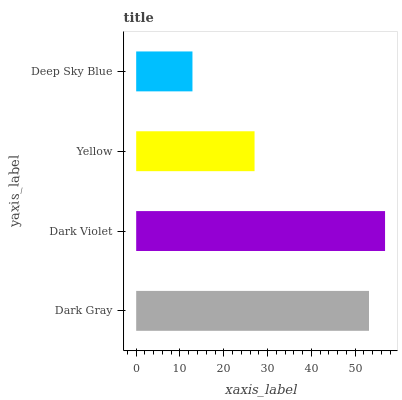Is Deep Sky Blue the minimum?
Answer yes or no. Yes. Is Dark Violet the maximum?
Answer yes or no. Yes. Is Yellow the minimum?
Answer yes or no. No. Is Yellow the maximum?
Answer yes or no. No. Is Dark Violet greater than Yellow?
Answer yes or no. Yes. Is Yellow less than Dark Violet?
Answer yes or no. Yes. Is Yellow greater than Dark Violet?
Answer yes or no. No. Is Dark Violet less than Yellow?
Answer yes or no. No. Is Dark Gray the high median?
Answer yes or no. Yes. Is Yellow the low median?
Answer yes or no. Yes. Is Deep Sky Blue the high median?
Answer yes or no. No. Is Deep Sky Blue the low median?
Answer yes or no. No. 